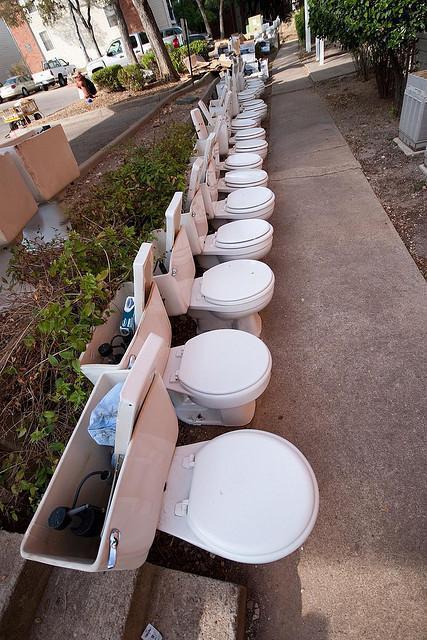How many urinals are pictured?
Give a very brief answer. 0. How many toilets are in the photo?
Give a very brief answer. 5. How many different trains are there?
Give a very brief answer. 0. 